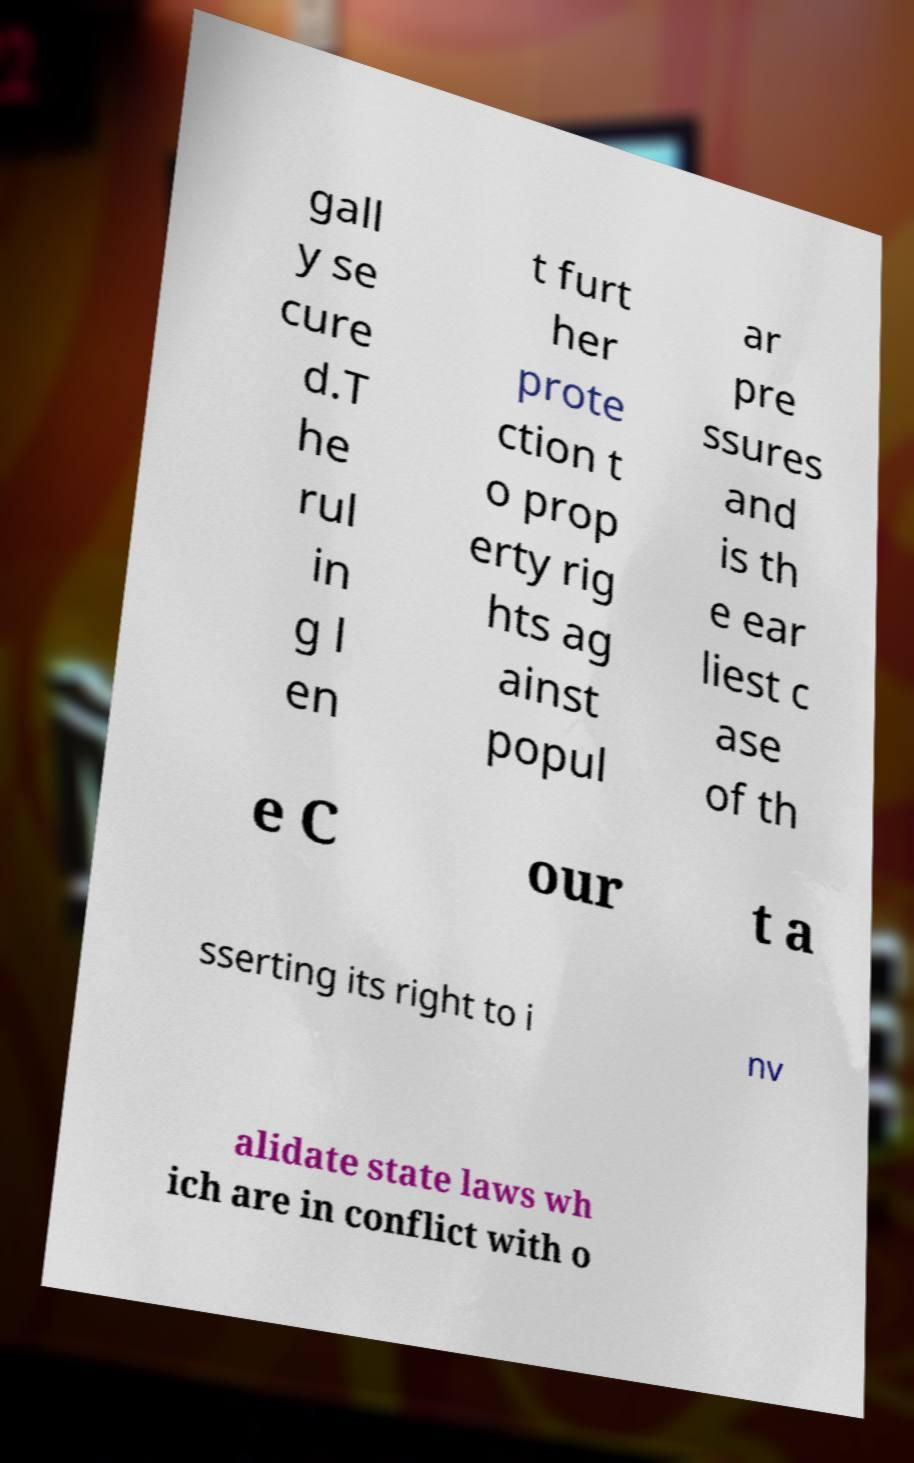I need the written content from this picture converted into text. Can you do that? gall y se cure d.T he rul in g l en t furt her prote ction t o prop erty rig hts ag ainst popul ar pre ssures and is th e ear liest c ase of th e C our t a sserting its right to i nv alidate state laws wh ich are in conflict with o 